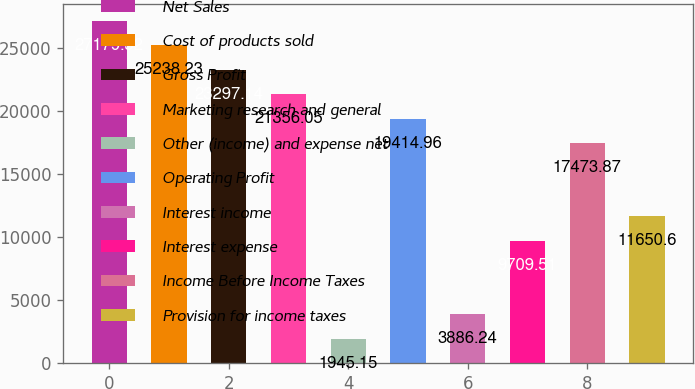Convert chart. <chart><loc_0><loc_0><loc_500><loc_500><bar_chart><fcel>Net Sales<fcel>Cost of products sold<fcel>Gross Profit<fcel>Marketing research and general<fcel>Other (income) and expense net<fcel>Operating Profit<fcel>Interest income<fcel>Interest expense<fcel>Income Before Income Taxes<fcel>Provision for income taxes<nl><fcel>27179.3<fcel>25238.2<fcel>23297.1<fcel>21356<fcel>1945.15<fcel>19415<fcel>3886.24<fcel>9709.51<fcel>17473.9<fcel>11650.6<nl></chart> 